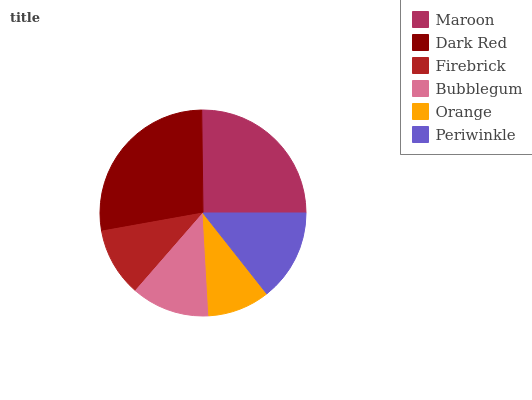Is Orange the minimum?
Answer yes or no. Yes. Is Dark Red the maximum?
Answer yes or no. Yes. Is Firebrick the minimum?
Answer yes or no. No. Is Firebrick the maximum?
Answer yes or no. No. Is Dark Red greater than Firebrick?
Answer yes or no. Yes. Is Firebrick less than Dark Red?
Answer yes or no. Yes. Is Firebrick greater than Dark Red?
Answer yes or no. No. Is Dark Red less than Firebrick?
Answer yes or no. No. Is Periwinkle the high median?
Answer yes or no. Yes. Is Bubblegum the low median?
Answer yes or no. Yes. Is Orange the high median?
Answer yes or no. No. Is Orange the low median?
Answer yes or no. No. 